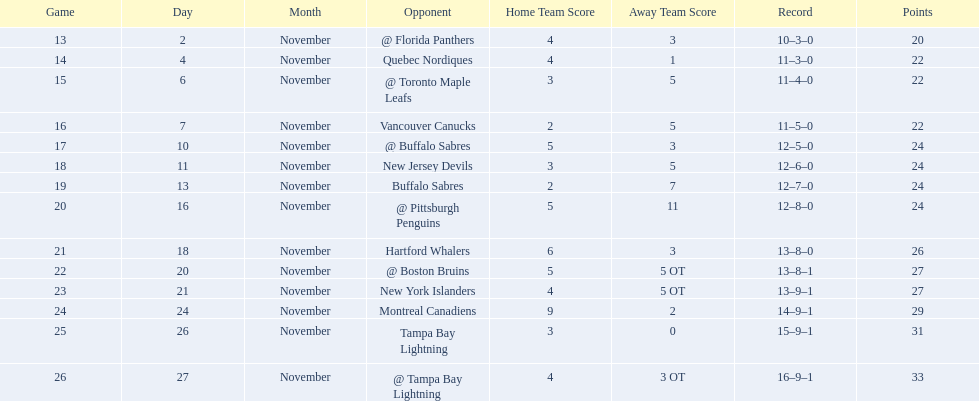Did the tampa bay lightning have the least amount of wins? Yes. 